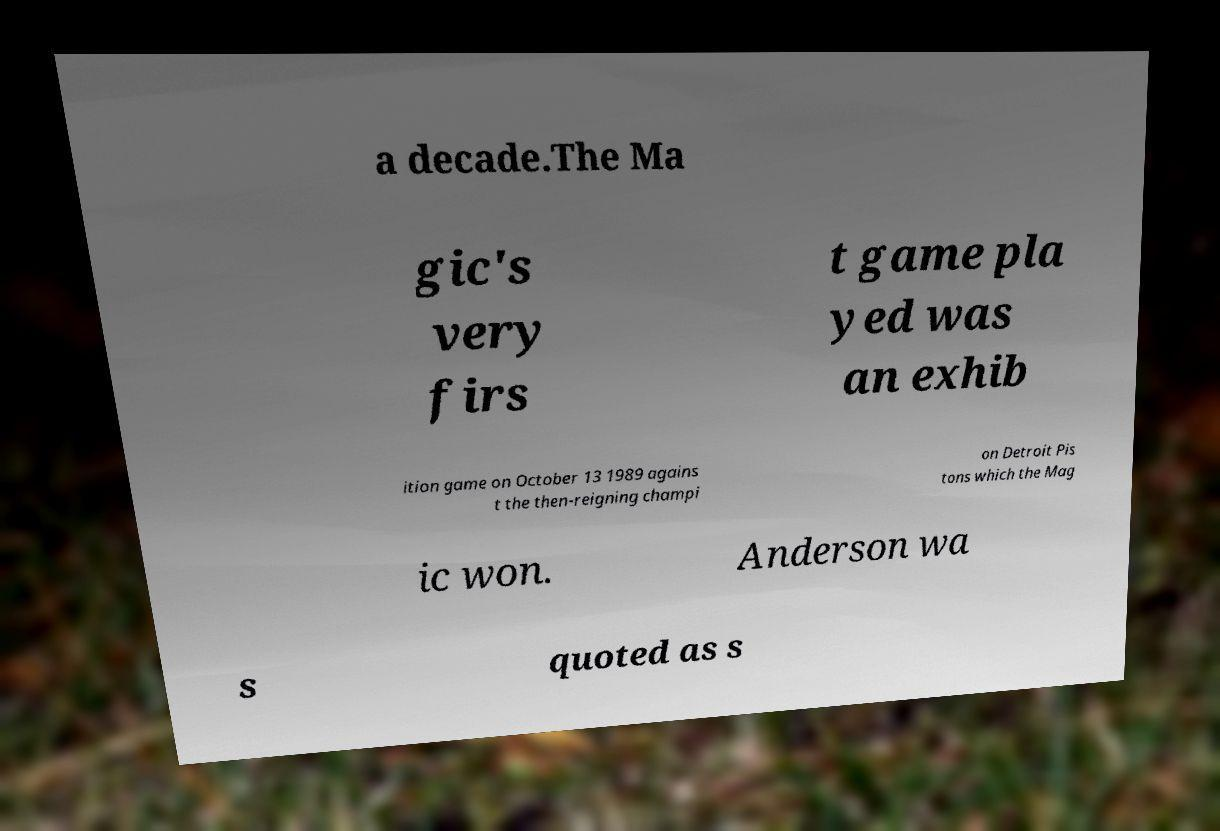Can you read and provide the text displayed in the image?This photo seems to have some interesting text. Can you extract and type it out for me? a decade.The Ma gic's very firs t game pla yed was an exhib ition game on October 13 1989 agains t the then-reigning champi on Detroit Pis tons which the Mag ic won. Anderson wa s quoted as s 